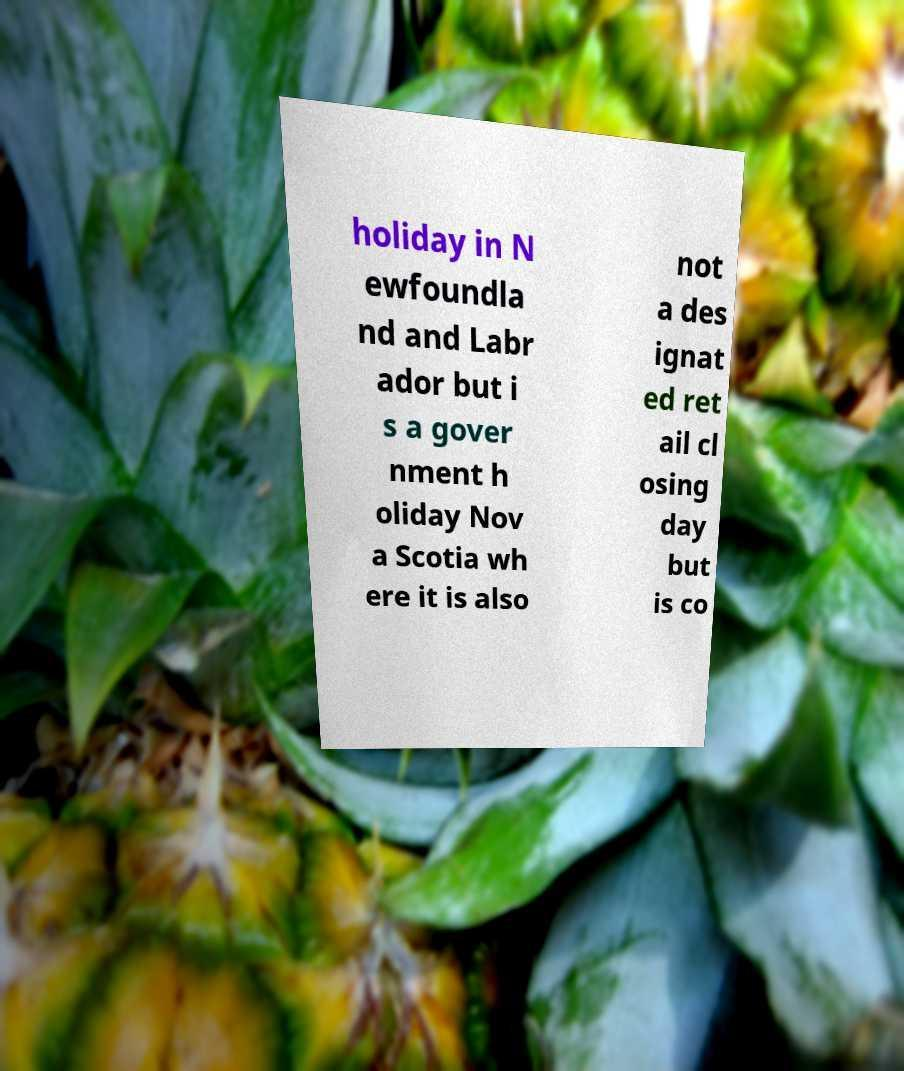Can you read and provide the text displayed in the image?This photo seems to have some interesting text. Can you extract and type it out for me? holiday in N ewfoundla nd and Labr ador but i s a gover nment h oliday Nov a Scotia wh ere it is also not a des ignat ed ret ail cl osing day but is co 